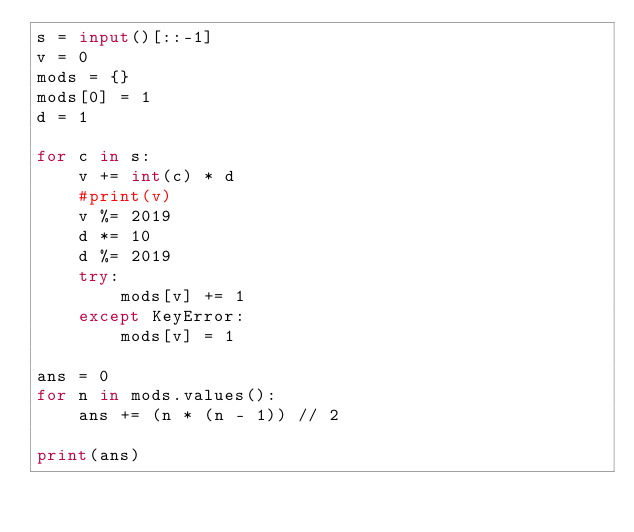<code> <loc_0><loc_0><loc_500><loc_500><_Python_>s = input()[::-1]
v = 0
mods = {}
mods[0] = 1
d = 1

for c in s:
    v += int(c) * d
    #print(v)
    v %= 2019
    d *= 10
    d %= 2019
    try:
        mods[v] += 1
    except KeyError:
        mods[v] = 1

ans = 0
for n in mods.values():
    ans += (n * (n - 1)) // 2

print(ans)</code> 